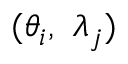<formula> <loc_0><loc_0><loc_500><loc_500>( { \theta _ { i } } , \, { \lambda _ { j } } )</formula> 